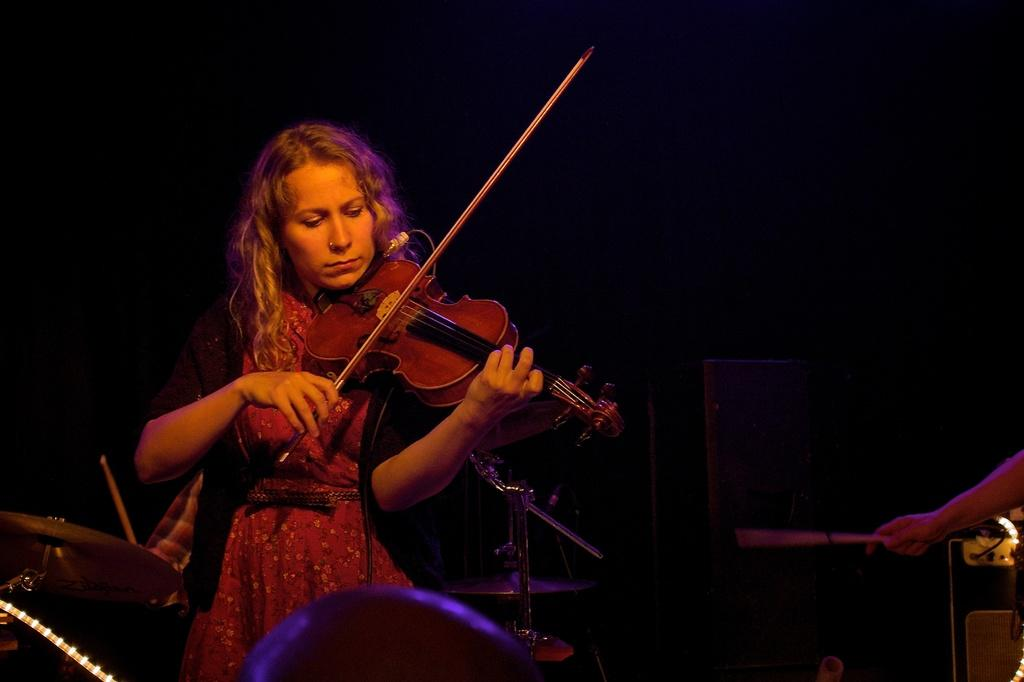Who is the main subject in the image? There is a woman in the image. What is the woman doing in the image? The woman is playing a violin. What else can be seen in the background of the image? There are other musical instruments in the background of the image. How would you describe the lighting in the image? The background of the image is dark. How many dolls are sitting on the woman's lap while she plays the violin? There are no dolls present in the image. What type of journey is the woman taking while playing the violin? The image does not depict a journey; it shows a woman playing a violin in a specific setting. 